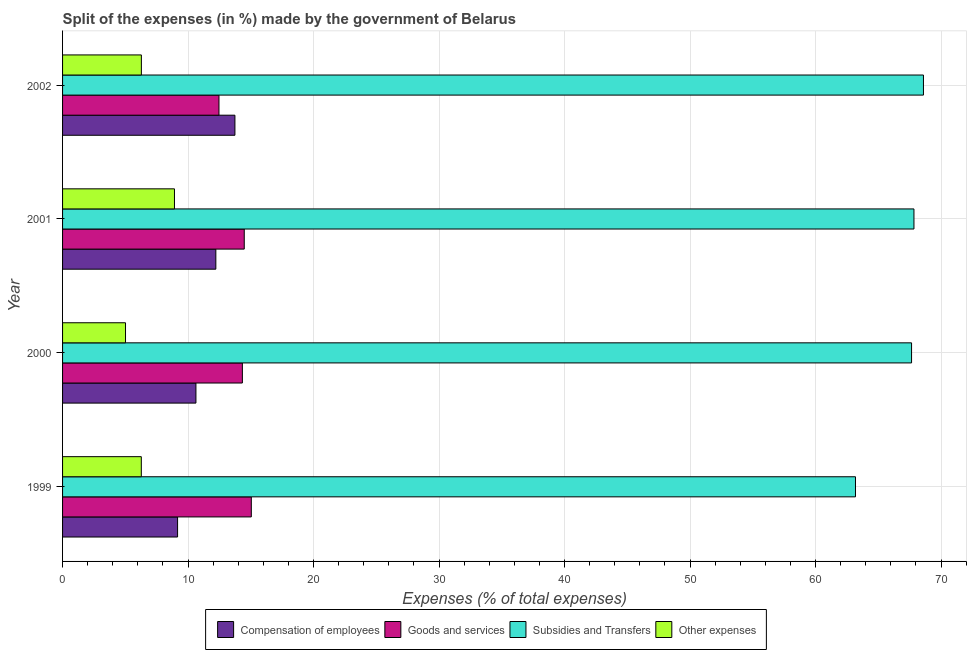Are the number of bars per tick equal to the number of legend labels?
Your answer should be compact. Yes. Are the number of bars on each tick of the Y-axis equal?
Give a very brief answer. Yes. How many bars are there on the 4th tick from the top?
Keep it short and to the point. 4. In how many cases, is the number of bars for a given year not equal to the number of legend labels?
Offer a very short reply. 0. What is the percentage of amount spent on subsidies in 2002?
Make the answer very short. 68.6. Across all years, what is the maximum percentage of amount spent on other expenses?
Make the answer very short. 8.92. Across all years, what is the minimum percentage of amount spent on subsidies?
Ensure brevity in your answer.  63.19. In which year was the percentage of amount spent on goods and services maximum?
Provide a short and direct response. 1999. In which year was the percentage of amount spent on goods and services minimum?
Give a very brief answer. 2002. What is the total percentage of amount spent on compensation of employees in the graph?
Provide a succinct answer. 45.74. What is the difference between the percentage of amount spent on compensation of employees in 1999 and that in 2000?
Make the answer very short. -1.46. What is the difference between the percentage of amount spent on compensation of employees in 2000 and the percentage of amount spent on subsidies in 1999?
Offer a terse response. -52.56. What is the average percentage of amount spent on compensation of employees per year?
Keep it short and to the point. 11.44. In the year 2001, what is the difference between the percentage of amount spent on compensation of employees and percentage of amount spent on goods and services?
Your answer should be very brief. -2.27. What is the ratio of the percentage of amount spent on goods and services in 2000 to that in 2002?
Your answer should be compact. 1.15. Is the difference between the percentage of amount spent on other expenses in 2000 and 2001 greater than the difference between the percentage of amount spent on subsidies in 2000 and 2001?
Give a very brief answer. No. What is the difference between the highest and the second highest percentage of amount spent on subsidies?
Ensure brevity in your answer.  0.76. What is the difference between the highest and the lowest percentage of amount spent on goods and services?
Your answer should be very brief. 2.58. What does the 2nd bar from the top in 2002 represents?
Give a very brief answer. Subsidies and Transfers. What does the 4th bar from the bottom in 2002 represents?
Ensure brevity in your answer.  Other expenses. What is the difference between two consecutive major ticks on the X-axis?
Offer a terse response. 10. Are the values on the major ticks of X-axis written in scientific E-notation?
Provide a short and direct response. No. Does the graph contain any zero values?
Give a very brief answer. No. Where does the legend appear in the graph?
Make the answer very short. Bottom center. How many legend labels are there?
Keep it short and to the point. 4. How are the legend labels stacked?
Keep it short and to the point. Horizontal. What is the title of the graph?
Give a very brief answer. Split of the expenses (in %) made by the government of Belarus. Does "Labor Taxes" appear as one of the legend labels in the graph?
Your response must be concise. No. What is the label or title of the X-axis?
Provide a short and direct response. Expenses (% of total expenses). What is the Expenses (% of total expenses) in Compensation of employees in 1999?
Give a very brief answer. 9.17. What is the Expenses (% of total expenses) of Goods and services in 1999?
Offer a terse response. 15.04. What is the Expenses (% of total expenses) of Subsidies and Transfers in 1999?
Make the answer very short. 63.19. What is the Expenses (% of total expenses) in Other expenses in 1999?
Your response must be concise. 6.28. What is the Expenses (% of total expenses) in Compensation of employees in 2000?
Provide a short and direct response. 10.63. What is the Expenses (% of total expenses) of Goods and services in 2000?
Give a very brief answer. 14.33. What is the Expenses (% of total expenses) in Subsidies and Transfers in 2000?
Ensure brevity in your answer.  67.66. What is the Expenses (% of total expenses) of Other expenses in 2000?
Provide a short and direct response. 5.02. What is the Expenses (% of total expenses) in Compensation of employees in 2001?
Ensure brevity in your answer.  12.21. What is the Expenses (% of total expenses) of Goods and services in 2001?
Give a very brief answer. 14.48. What is the Expenses (% of total expenses) of Subsidies and Transfers in 2001?
Your answer should be compact. 67.85. What is the Expenses (% of total expenses) of Other expenses in 2001?
Your answer should be very brief. 8.92. What is the Expenses (% of total expenses) of Compensation of employees in 2002?
Make the answer very short. 13.73. What is the Expenses (% of total expenses) of Goods and services in 2002?
Your answer should be very brief. 12.46. What is the Expenses (% of total expenses) of Subsidies and Transfers in 2002?
Make the answer very short. 68.6. What is the Expenses (% of total expenses) of Other expenses in 2002?
Your answer should be very brief. 6.28. Across all years, what is the maximum Expenses (% of total expenses) in Compensation of employees?
Make the answer very short. 13.73. Across all years, what is the maximum Expenses (% of total expenses) of Goods and services?
Keep it short and to the point. 15.04. Across all years, what is the maximum Expenses (% of total expenses) of Subsidies and Transfers?
Give a very brief answer. 68.6. Across all years, what is the maximum Expenses (% of total expenses) in Other expenses?
Offer a very short reply. 8.92. Across all years, what is the minimum Expenses (% of total expenses) in Compensation of employees?
Ensure brevity in your answer.  9.17. Across all years, what is the minimum Expenses (% of total expenses) of Goods and services?
Make the answer very short. 12.46. Across all years, what is the minimum Expenses (% of total expenses) of Subsidies and Transfers?
Give a very brief answer. 63.19. Across all years, what is the minimum Expenses (% of total expenses) in Other expenses?
Your response must be concise. 5.02. What is the total Expenses (% of total expenses) in Compensation of employees in the graph?
Ensure brevity in your answer.  45.74. What is the total Expenses (% of total expenses) in Goods and services in the graph?
Your answer should be compact. 56.31. What is the total Expenses (% of total expenses) of Subsidies and Transfers in the graph?
Your answer should be compact. 267.29. What is the total Expenses (% of total expenses) of Other expenses in the graph?
Give a very brief answer. 26.49. What is the difference between the Expenses (% of total expenses) of Compensation of employees in 1999 and that in 2000?
Provide a short and direct response. -1.46. What is the difference between the Expenses (% of total expenses) in Goods and services in 1999 and that in 2000?
Your answer should be compact. 0.71. What is the difference between the Expenses (% of total expenses) of Subsidies and Transfers in 1999 and that in 2000?
Offer a very short reply. -4.47. What is the difference between the Expenses (% of total expenses) of Other expenses in 1999 and that in 2000?
Provide a succinct answer. 1.26. What is the difference between the Expenses (% of total expenses) of Compensation of employees in 1999 and that in 2001?
Offer a terse response. -3.05. What is the difference between the Expenses (% of total expenses) of Goods and services in 1999 and that in 2001?
Provide a succinct answer. 0.56. What is the difference between the Expenses (% of total expenses) in Subsidies and Transfers in 1999 and that in 2001?
Your response must be concise. -4.66. What is the difference between the Expenses (% of total expenses) in Other expenses in 1999 and that in 2001?
Keep it short and to the point. -2.64. What is the difference between the Expenses (% of total expenses) in Compensation of employees in 1999 and that in 2002?
Keep it short and to the point. -4.57. What is the difference between the Expenses (% of total expenses) in Goods and services in 1999 and that in 2002?
Make the answer very short. 2.58. What is the difference between the Expenses (% of total expenses) of Subsidies and Transfers in 1999 and that in 2002?
Offer a terse response. -5.42. What is the difference between the Expenses (% of total expenses) in Other expenses in 1999 and that in 2002?
Provide a succinct answer. -0.01. What is the difference between the Expenses (% of total expenses) in Compensation of employees in 2000 and that in 2001?
Your answer should be very brief. -1.59. What is the difference between the Expenses (% of total expenses) in Goods and services in 2000 and that in 2001?
Ensure brevity in your answer.  -0.15. What is the difference between the Expenses (% of total expenses) in Subsidies and Transfers in 2000 and that in 2001?
Keep it short and to the point. -0.19. What is the difference between the Expenses (% of total expenses) of Other expenses in 2000 and that in 2001?
Give a very brief answer. -3.9. What is the difference between the Expenses (% of total expenses) of Compensation of employees in 2000 and that in 2002?
Make the answer very short. -3.11. What is the difference between the Expenses (% of total expenses) in Goods and services in 2000 and that in 2002?
Ensure brevity in your answer.  1.87. What is the difference between the Expenses (% of total expenses) in Subsidies and Transfers in 2000 and that in 2002?
Ensure brevity in your answer.  -0.95. What is the difference between the Expenses (% of total expenses) in Other expenses in 2000 and that in 2002?
Your answer should be compact. -1.26. What is the difference between the Expenses (% of total expenses) in Compensation of employees in 2001 and that in 2002?
Your response must be concise. -1.52. What is the difference between the Expenses (% of total expenses) in Goods and services in 2001 and that in 2002?
Ensure brevity in your answer.  2.02. What is the difference between the Expenses (% of total expenses) in Subsidies and Transfers in 2001 and that in 2002?
Your response must be concise. -0.76. What is the difference between the Expenses (% of total expenses) in Other expenses in 2001 and that in 2002?
Give a very brief answer. 2.64. What is the difference between the Expenses (% of total expenses) in Compensation of employees in 1999 and the Expenses (% of total expenses) in Goods and services in 2000?
Make the answer very short. -5.16. What is the difference between the Expenses (% of total expenses) of Compensation of employees in 1999 and the Expenses (% of total expenses) of Subsidies and Transfers in 2000?
Provide a succinct answer. -58.49. What is the difference between the Expenses (% of total expenses) of Compensation of employees in 1999 and the Expenses (% of total expenses) of Other expenses in 2000?
Your response must be concise. 4.15. What is the difference between the Expenses (% of total expenses) of Goods and services in 1999 and the Expenses (% of total expenses) of Subsidies and Transfers in 2000?
Ensure brevity in your answer.  -52.61. What is the difference between the Expenses (% of total expenses) of Goods and services in 1999 and the Expenses (% of total expenses) of Other expenses in 2000?
Your answer should be compact. 10.03. What is the difference between the Expenses (% of total expenses) of Subsidies and Transfers in 1999 and the Expenses (% of total expenses) of Other expenses in 2000?
Provide a short and direct response. 58.17. What is the difference between the Expenses (% of total expenses) in Compensation of employees in 1999 and the Expenses (% of total expenses) in Goods and services in 2001?
Your answer should be very brief. -5.31. What is the difference between the Expenses (% of total expenses) in Compensation of employees in 1999 and the Expenses (% of total expenses) in Subsidies and Transfers in 2001?
Your answer should be compact. -58.68. What is the difference between the Expenses (% of total expenses) in Compensation of employees in 1999 and the Expenses (% of total expenses) in Other expenses in 2001?
Provide a short and direct response. 0.25. What is the difference between the Expenses (% of total expenses) of Goods and services in 1999 and the Expenses (% of total expenses) of Subsidies and Transfers in 2001?
Ensure brevity in your answer.  -52.8. What is the difference between the Expenses (% of total expenses) in Goods and services in 1999 and the Expenses (% of total expenses) in Other expenses in 2001?
Offer a very short reply. 6.12. What is the difference between the Expenses (% of total expenses) of Subsidies and Transfers in 1999 and the Expenses (% of total expenses) of Other expenses in 2001?
Your answer should be compact. 54.27. What is the difference between the Expenses (% of total expenses) of Compensation of employees in 1999 and the Expenses (% of total expenses) of Goods and services in 2002?
Make the answer very short. -3.3. What is the difference between the Expenses (% of total expenses) of Compensation of employees in 1999 and the Expenses (% of total expenses) of Subsidies and Transfers in 2002?
Provide a short and direct response. -59.44. What is the difference between the Expenses (% of total expenses) of Compensation of employees in 1999 and the Expenses (% of total expenses) of Other expenses in 2002?
Make the answer very short. 2.88. What is the difference between the Expenses (% of total expenses) in Goods and services in 1999 and the Expenses (% of total expenses) in Subsidies and Transfers in 2002?
Your answer should be compact. -53.56. What is the difference between the Expenses (% of total expenses) in Goods and services in 1999 and the Expenses (% of total expenses) in Other expenses in 2002?
Offer a very short reply. 8.76. What is the difference between the Expenses (% of total expenses) in Subsidies and Transfers in 1999 and the Expenses (% of total expenses) in Other expenses in 2002?
Your response must be concise. 56.91. What is the difference between the Expenses (% of total expenses) of Compensation of employees in 2000 and the Expenses (% of total expenses) of Goods and services in 2001?
Offer a very short reply. -3.85. What is the difference between the Expenses (% of total expenses) of Compensation of employees in 2000 and the Expenses (% of total expenses) of Subsidies and Transfers in 2001?
Provide a short and direct response. -57.22. What is the difference between the Expenses (% of total expenses) of Compensation of employees in 2000 and the Expenses (% of total expenses) of Other expenses in 2001?
Offer a terse response. 1.71. What is the difference between the Expenses (% of total expenses) in Goods and services in 2000 and the Expenses (% of total expenses) in Subsidies and Transfers in 2001?
Offer a terse response. -53.52. What is the difference between the Expenses (% of total expenses) in Goods and services in 2000 and the Expenses (% of total expenses) in Other expenses in 2001?
Give a very brief answer. 5.41. What is the difference between the Expenses (% of total expenses) of Subsidies and Transfers in 2000 and the Expenses (% of total expenses) of Other expenses in 2001?
Your answer should be very brief. 58.74. What is the difference between the Expenses (% of total expenses) in Compensation of employees in 2000 and the Expenses (% of total expenses) in Goods and services in 2002?
Your response must be concise. -1.83. What is the difference between the Expenses (% of total expenses) in Compensation of employees in 2000 and the Expenses (% of total expenses) in Subsidies and Transfers in 2002?
Your response must be concise. -57.97. What is the difference between the Expenses (% of total expenses) of Compensation of employees in 2000 and the Expenses (% of total expenses) of Other expenses in 2002?
Give a very brief answer. 4.35. What is the difference between the Expenses (% of total expenses) in Goods and services in 2000 and the Expenses (% of total expenses) in Subsidies and Transfers in 2002?
Make the answer very short. -54.27. What is the difference between the Expenses (% of total expenses) of Goods and services in 2000 and the Expenses (% of total expenses) of Other expenses in 2002?
Your response must be concise. 8.05. What is the difference between the Expenses (% of total expenses) in Subsidies and Transfers in 2000 and the Expenses (% of total expenses) in Other expenses in 2002?
Give a very brief answer. 61.37. What is the difference between the Expenses (% of total expenses) in Compensation of employees in 2001 and the Expenses (% of total expenses) in Goods and services in 2002?
Ensure brevity in your answer.  -0.25. What is the difference between the Expenses (% of total expenses) of Compensation of employees in 2001 and the Expenses (% of total expenses) of Subsidies and Transfers in 2002?
Offer a very short reply. -56.39. What is the difference between the Expenses (% of total expenses) of Compensation of employees in 2001 and the Expenses (% of total expenses) of Other expenses in 2002?
Provide a short and direct response. 5.93. What is the difference between the Expenses (% of total expenses) in Goods and services in 2001 and the Expenses (% of total expenses) in Subsidies and Transfers in 2002?
Give a very brief answer. -54.12. What is the difference between the Expenses (% of total expenses) of Goods and services in 2001 and the Expenses (% of total expenses) of Other expenses in 2002?
Your answer should be very brief. 8.2. What is the difference between the Expenses (% of total expenses) in Subsidies and Transfers in 2001 and the Expenses (% of total expenses) in Other expenses in 2002?
Ensure brevity in your answer.  61.56. What is the average Expenses (% of total expenses) of Compensation of employees per year?
Give a very brief answer. 11.44. What is the average Expenses (% of total expenses) in Goods and services per year?
Offer a terse response. 14.08. What is the average Expenses (% of total expenses) in Subsidies and Transfers per year?
Offer a very short reply. 66.82. What is the average Expenses (% of total expenses) of Other expenses per year?
Provide a succinct answer. 6.62. In the year 1999, what is the difference between the Expenses (% of total expenses) in Compensation of employees and Expenses (% of total expenses) in Goods and services?
Your answer should be compact. -5.88. In the year 1999, what is the difference between the Expenses (% of total expenses) in Compensation of employees and Expenses (% of total expenses) in Subsidies and Transfers?
Provide a short and direct response. -54.02. In the year 1999, what is the difference between the Expenses (% of total expenses) of Compensation of employees and Expenses (% of total expenses) of Other expenses?
Your answer should be very brief. 2.89. In the year 1999, what is the difference between the Expenses (% of total expenses) in Goods and services and Expenses (% of total expenses) in Subsidies and Transfers?
Offer a terse response. -48.15. In the year 1999, what is the difference between the Expenses (% of total expenses) in Goods and services and Expenses (% of total expenses) in Other expenses?
Your answer should be compact. 8.77. In the year 1999, what is the difference between the Expenses (% of total expenses) in Subsidies and Transfers and Expenses (% of total expenses) in Other expenses?
Give a very brief answer. 56.91. In the year 2000, what is the difference between the Expenses (% of total expenses) in Compensation of employees and Expenses (% of total expenses) in Goods and services?
Give a very brief answer. -3.7. In the year 2000, what is the difference between the Expenses (% of total expenses) in Compensation of employees and Expenses (% of total expenses) in Subsidies and Transfers?
Your response must be concise. -57.03. In the year 2000, what is the difference between the Expenses (% of total expenses) in Compensation of employees and Expenses (% of total expenses) in Other expenses?
Make the answer very short. 5.61. In the year 2000, what is the difference between the Expenses (% of total expenses) of Goods and services and Expenses (% of total expenses) of Subsidies and Transfers?
Provide a short and direct response. -53.33. In the year 2000, what is the difference between the Expenses (% of total expenses) in Goods and services and Expenses (% of total expenses) in Other expenses?
Offer a very short reply. 9.31. In the year 2000, what is the difference between the Expenses (% of total expenses) of Subsidies and Transfers and Expenses (% of total expenses) of Other expenses?
Offer a terse response. 62.64. In the year 2001, what is the difference between the Expenses (% of total expenses) in Compensation of employees and Expenses (% of total expenses) in Goods and services?
Keep it short and to the point. -2.26. In the year 2001, what is the difference between the Expenses (% of total expenses) in Compensation of employees and Expenses (% of total expenses) in Subsidies and Transfers?
Offer a very short reply. -55.63. In the year 2001, what is the difference between the Expenses (% of total expenses) of Compensation of employees and Expenses (% of total expenses) of Other expenses?
Provide a short and direct response. 3.3. In the year 2001, what is the difference between the Expenses (% of total expenses) in Goods and services and Expenses (% of total expenses) in Subsidies and Transfers?
Make the answer very short. -53.37. In the year 2001, what is the difference between the Expenses (% of total expenses) of Goods and services and Expenses (% of total expenses) of Other expenses?
Give a very brief answer. 5.56. In the year 2001, what is the difference between the Expenses (% of total expenses) in Subsidies and Transfers and Expenses (% of total expenses) in Other expenses?
Offer a very short reply. 58.93. In the year 2002, what is the difference between the Expenses (% of total expenses) of Compensation of employees and Expenses (% of total expenses) of Goods and services?
Make the answer very short. 1.27. In the year 2002, what is the difference between the Expenses (% of total expenses) in Compensation of employees and Expenses (% of total expenses) in Subsidies and Transfers?
Your answer should be compact. -54.87. In the year 2002, what is the difference between the Expenses (% of total expenses) of Compensation of employees and Expenses (% of total expenses) of Other expenses?
Give a very brief answer. 7.45. In the year 2002, what is the difference between the Expenses (% of total expenses) of Goods and services and Expenses (% of total expenses) of Subsidies and Transfers?
Give a very brief answer. -56.14. In the year 2002, what is the difference between the Expenses (% of total expenses) of Goods and services and Expenses (% of total expenses) of Other expenses?
Make the answer very short. 6.18. In the year 2002, what is the difference between the Expenses (% of total expenses) in Subsidies and Transfers and Expenses (% of total expenses) in Other expenses?
Make the answer very short. 62.32. What is the ratio of the Expenses (% of total expenses) of Compensation of employees in 1999 to that in 2000?
Make the answer very short. 0.86. What is the ratio of the Expenses (% of total expenses) in Goods and services in 1999 to that in 2000?
Offer a terse response. 1.05. What is the ratio of the Expenses (% of total expenses) in Subsidies and Transfers in 1999 to that in 2000?
Your answer should be very brief. 0.93. What is the ratio of the Expenses (% of total expenses) of Other expenses in 1999 to that in 2000?
Provide a short and direct response. 1.25. What is the ratio of the Expenses (% of total expenses) of Compensation of employees in 1999 to that in 2001?
Offer a very short reply. 0.75. What is the ratio of the Expenses (% of total expenses) of Goods and services in 1999 to that in 2001?
Your answer should be compact. 1.04. What is the ratio of the Expenses (% of total expenses) of Subsidies and Transfers in 1999 to that in 2001?
Ensure brevity in your answer.  0.93. What is the ratio of the Expenses (% of total expenses) of Other expenses in 1999 to that in 2001?
Make the answer very short. 0.7. What is the ratio of the Expenses (% of total expenses) in Compensation of employees in 1999 to that in 2002?
Keep it short and to the point. 0.67. What is the ratio of the Expenses (% of total expenses) of Goods and services in 1999 to that in 2002?
Offer a terse response. 1.21. What is the ratio of the Expenses (% of total expenses) of Subsidies and Transfers in 1999 to that in 2002?
Provide a succinct answer. 0.92. What is the ratio of the Expenses (% of total expenses) of Compensation of employees in 2000 to that in 2001?
Make the answer very short. 0.87. What is the ratio of the Expenses (% of total expenses) of Subsidies and Transfers in 2000 to that in 2001?
Offer a very short reply. 1. What is the ratio of the Expenses (% of total expenses) of Other expenses in 2000 to that in 2001?
Your answer should be compact. 0.56. What is the ratio of the Expenses (% of total expenses) of Compensation of employees in 2000 to that in 2002?
Make the answer very short. 0.77. What is the ratio of the Expenses (% of total expenses) in Goods and services in 2000 to that in 2002?
Make the answer very short. 1.15. What is the ratio of the Expenses (% of total expenses) in Subsidies and Transfers in 2000 to that in 2002?
Your answer should be compact. 0.99. What is the ratio of the Expenses (% of total expenses) of Other expenses in 2000 to that in 2002?
Ensure brevity in your answer.  0.8. What is the ratio of the Expenses (% of total expenses) in Compensation of employees in 2001 to that in 2002?
Provide a succinct answer. 0.89. What is the ratio of the Expenses (% of total expenses) in Goods and services in 2001 to that in 2002?
Offer a very short reply. 1.16. What is the ratio of the Expenses (% of total expenses) in Subsidies and Transfers in 2001 to that in 2002?
Provide a succinct answer. 0.99. What is the ratio of the Expenses (% of total expenses) of Other expenses in 2001 to that in 2002?
Make the answer very short. 1.42. What is the difference between the highest and the second highest Expenses (% of total expenses) in Compensation of employees?
Keep it short and to the point. 1.52. What is the difference between the highest and the second highest Expenses (% of total expenses) in Goods and services?
Ensure brevity in your answer.  0.56. What is the difference between the highest and the second highest Expenses (% of total expenses) of Subsidies and Transfers?
Your answer should be compact. 0.76. What is the difference between the highest and the second highest Expenses (% of total expenses) in Other expenses?
Ensure brevity in your answer.  2.64. What is the difference between the highest and the lowest Expenses (% of total expenses) of Compensation of employees?
Give a very brief answer. 4.57. What is the difference between the highest and the lowest Expenses (% of total expenses) of Goods and services?
Give a very brief answer. 2.58. What is the difference between the highest and the lowest Expenses (% of total expenses) of Subsidies and Transfers?
Give a very brief answer. 5.42. What is the difference between the highest and the lowest Expenses (% of total expenses) in Other expenses?
Ensure brevity in your answer.  3.9. 